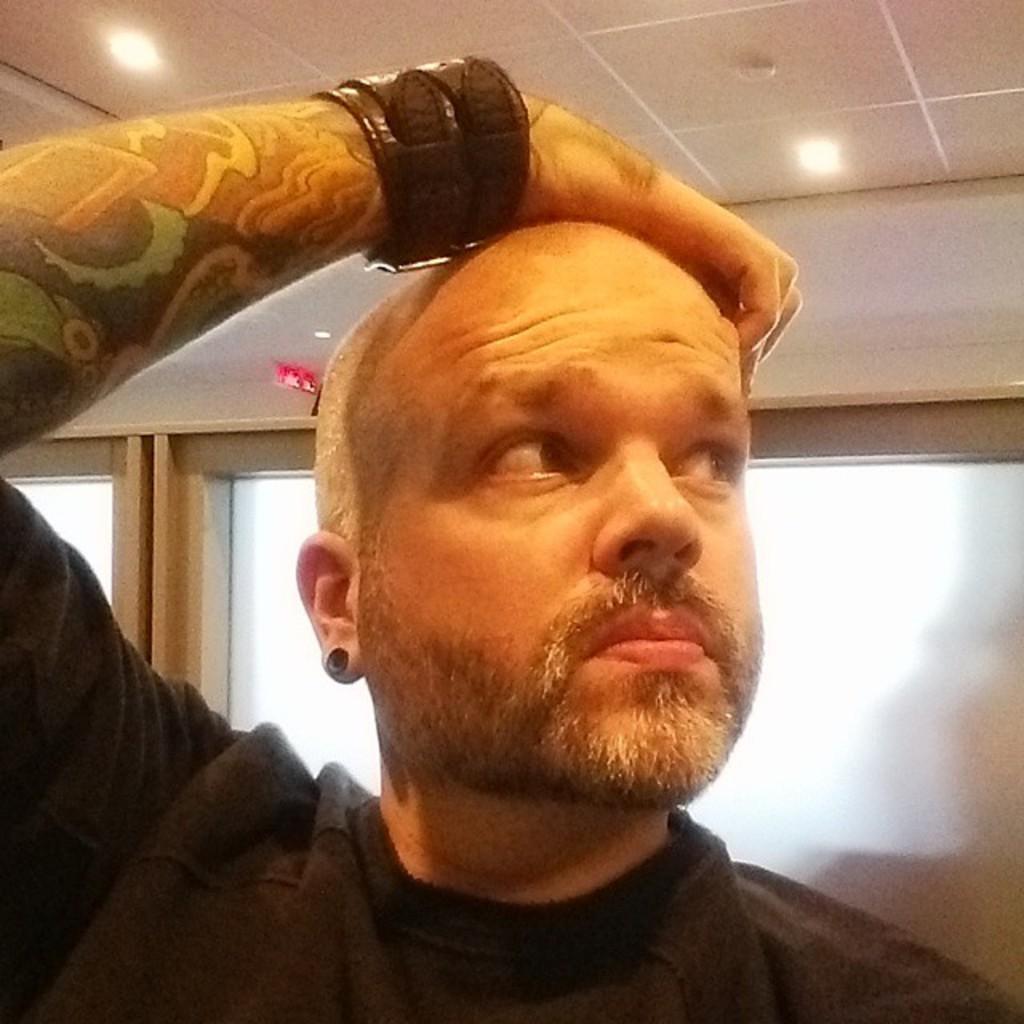Describe this image in one or two sentences. In the image there is a man, he is looking towards his right and he is wearing some band to his hand and he kept his hand on his head, behind the man there are two windows. 